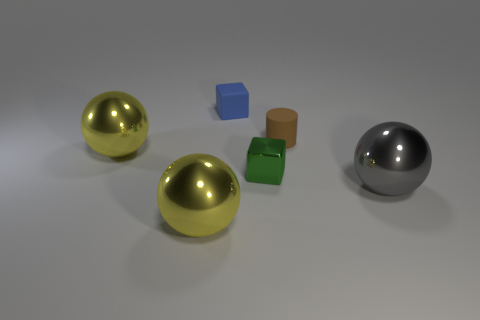Is the material of the big yellow object that is in front of the green thing the same as the small brown object on the left side of the gray ball? The large yellow object appears to have a reflective, perhaps metallic finish, consistent with the look of brass or gold, while the small brown object has a matte finish and appears to be made of a different material, possibly cardboard or wood. From this visual assessment, it seems unlikely that they are made of the same material. 